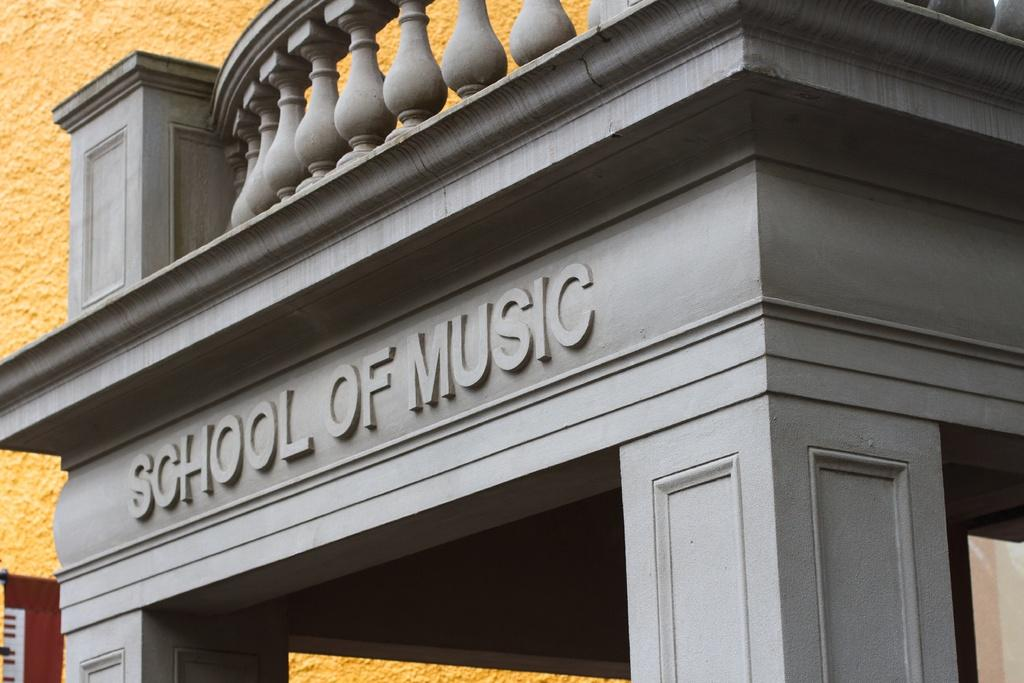What is the main structure visible in the image? There is a building in the image. Can you describe any additional features of the building? There is text on the building. How many tigers can be seen on the plantation in the image? There are no tigers or plantations present in the image; it features a building with text on it. 